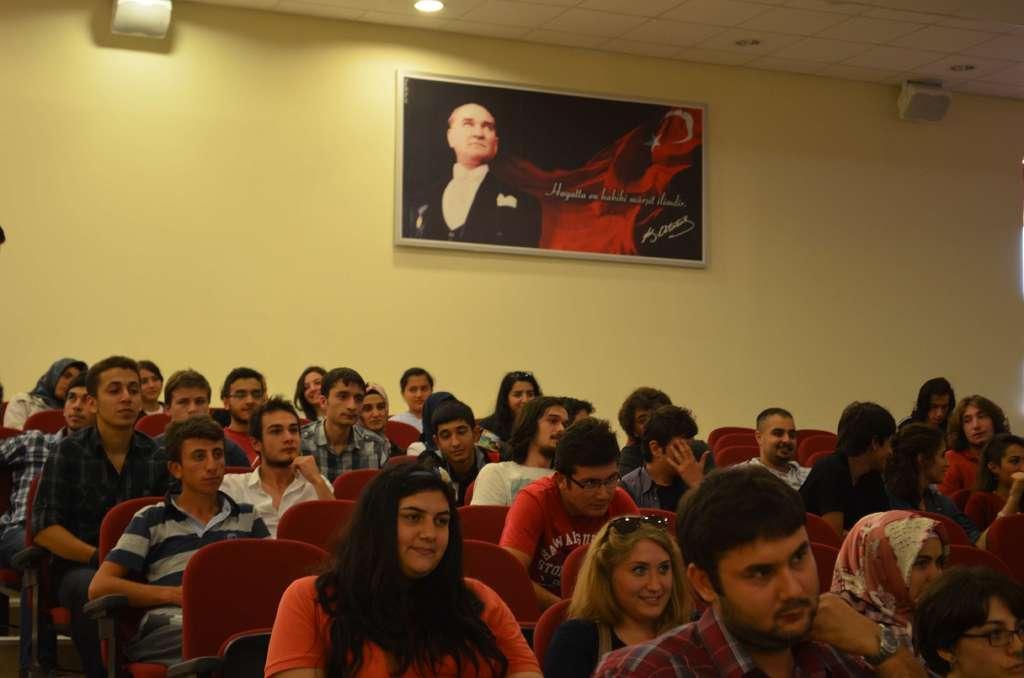How would you summarize this image in a sentence or two? In this image I can see group of people sitting. In the background I can see the frame attached to the wall and the wall is in yellow color and I can see few lights. 